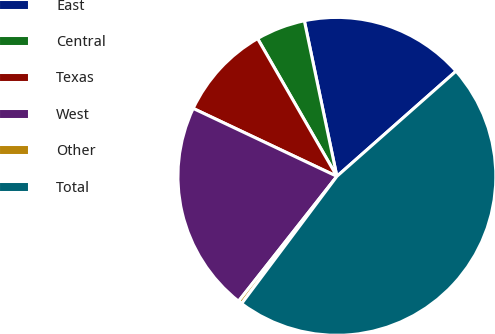Convert chart. <chart><loc_0><loc_0><loc_500><loc_500><pie_chart><fcel>East<fcel>Central<fcel>Texas<fcel>West<fcel>Other<fcel>Total<nl><fcel>16.77%<fcel>5.03%<fcel>9.66%<fcel>21.41%<fcel>0.39%<fcel>46.74%<nl></chart> 